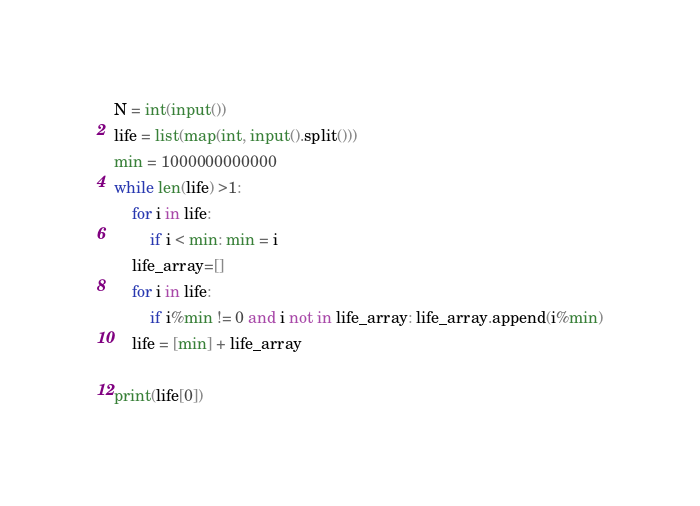<code> <loc_0><loc_0><loc_500><loc_500><_Python_>N = int(input())
life = list(map(int, input().split()))
min = 1000000000000
while len(life) >1:
    for i in life:
        if i < min: min = i
    life_array=[]
    for i in life:
        if i%min != 0 and i not in life_array: life_array.append(i%min)
    life = [min] + life_array

print(life[0])</code> 